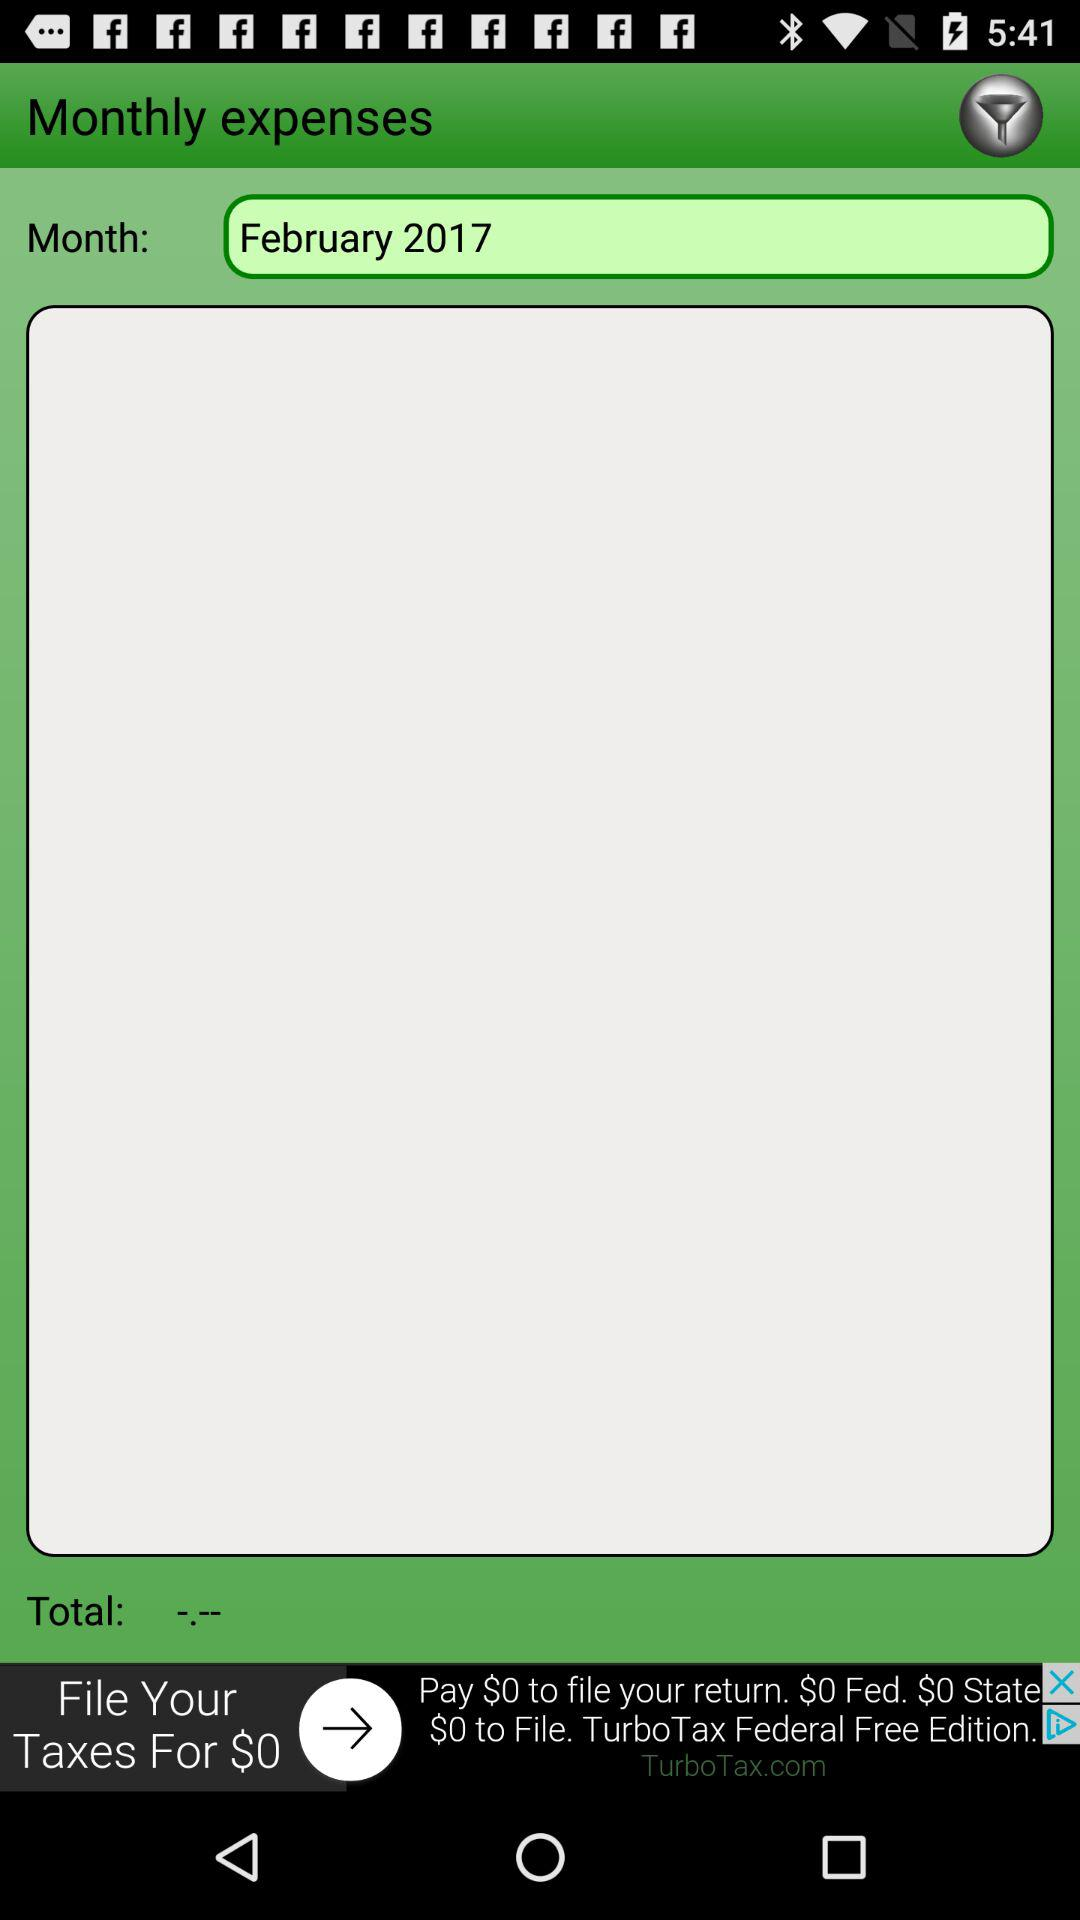How many months have expenses been entered for?
Answer the question using a single word or phrase. 1 